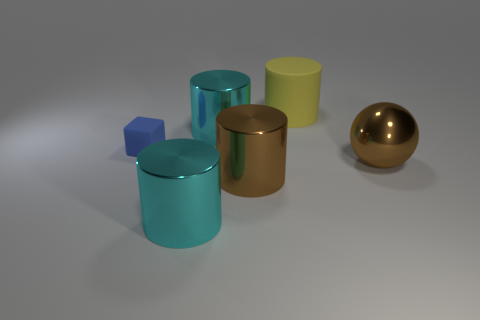Subtract all yellow cylinders. How many cylinders are left? 3 Subtract all gray spheres. How many cyan cylinders are left? 2 Add 1 large cyan things. How many objects exist? 7 Subtract all brown cylinders. How many cylinders are left? 3 Add 3 yellow rubber cylinders. How many yellow rubber cylinders are left? 4 Add 4 small yellow shiny objects. How many small yellow shiny objects exist? 4 Subtract 0 yellow spheres. How many objects are left? 6 Subtract all blocks. How many objects are left? 5 Subtract all red blocks. Subtract all blue balls. How many blocks are left? 1 Subtract all large brown objects. Subtract all yellow cylinders. How many objects are left? 3 